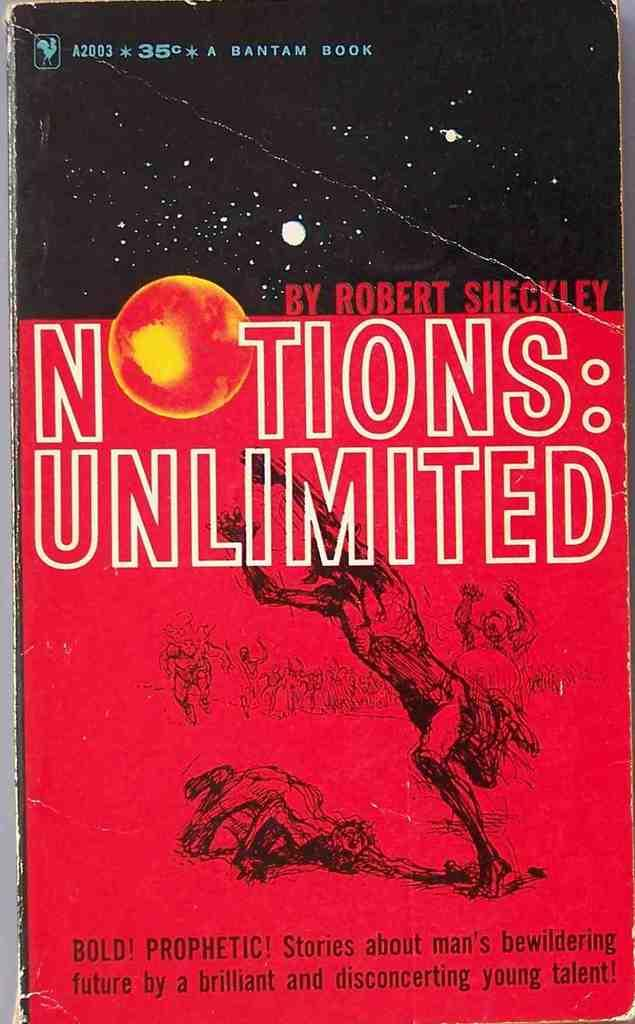<image>
Create a compact narrative representing the image presented. A book by Robert Sheckley has a red and black cover. 